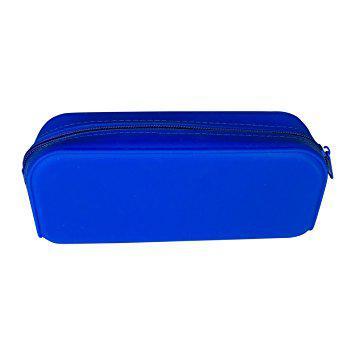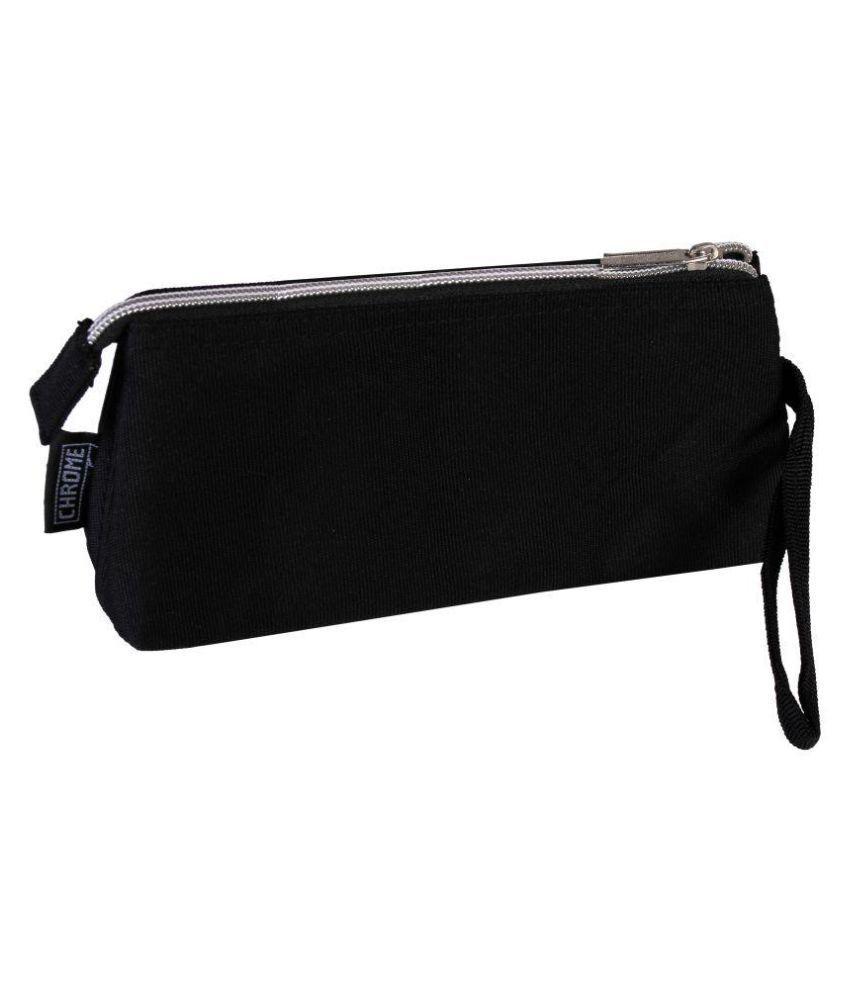The first image is the image on the left, the second image is the image on the right. Examine the images to the left and right. Is the description "One case is zipped shut and displayed horizontally, while the other is a blue multi-zippered compartment case displayed upright, open, and fanned out." accurate? Answer yes or no. No. 